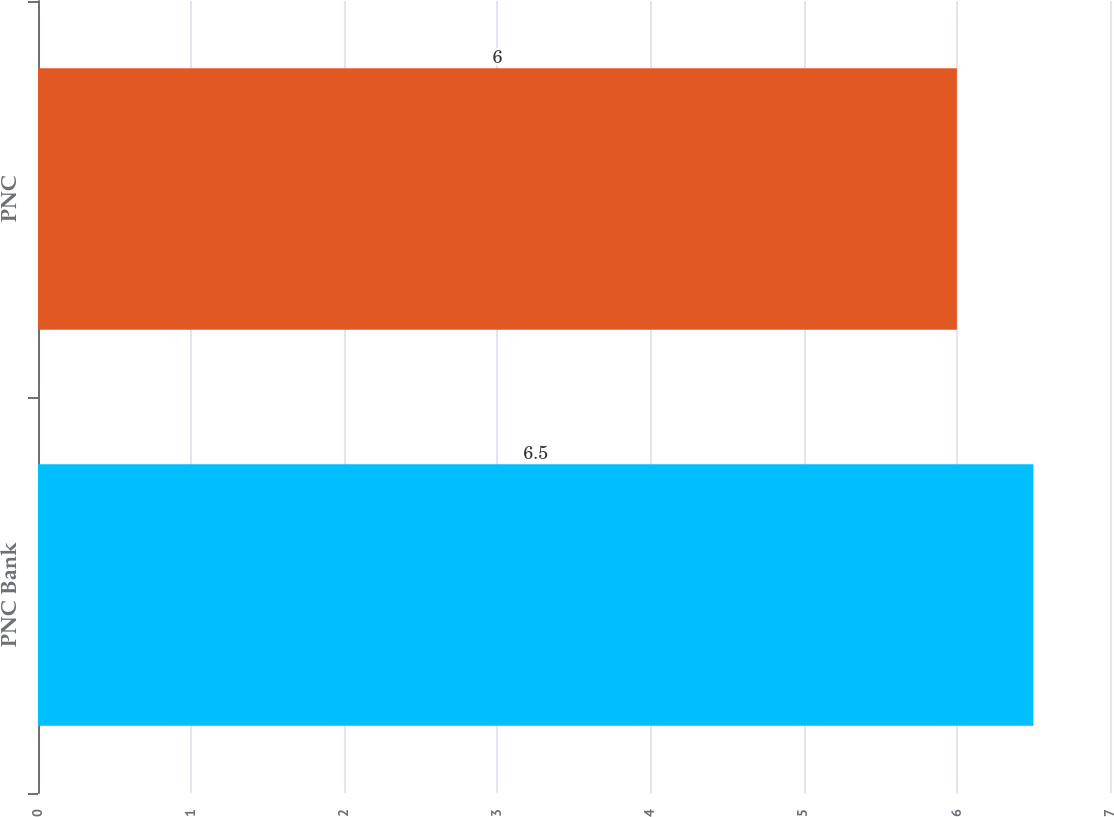<chart> <loc_0><loc_0><loc_500><loc_500><bar_chart><fcel>PNC Bank<fcel>PNC<nl><fcel>6.5<fcel>6<nl></chart> 